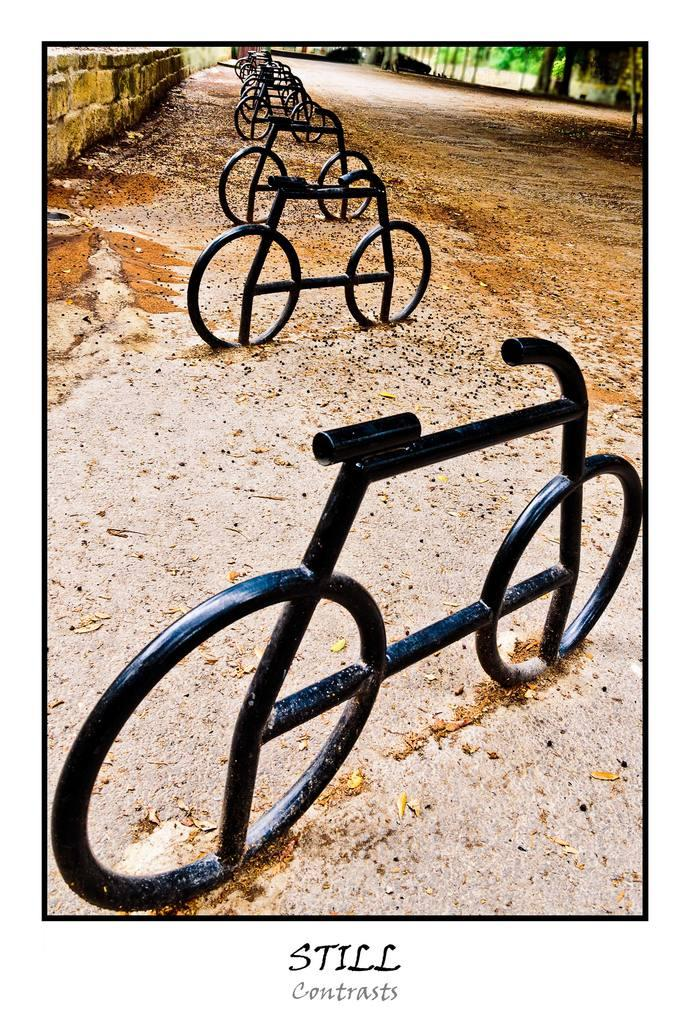What type of objects are present in the image? There are metal rods in the image. What natural elements can be seen in the image? There are trees in the image. Is there any text present in the image? Yes, there is text at the bottom of the image. What type of help can be seen being provided in the image? There is no help being provided in the image; it only features metal rods, trees, and text. 